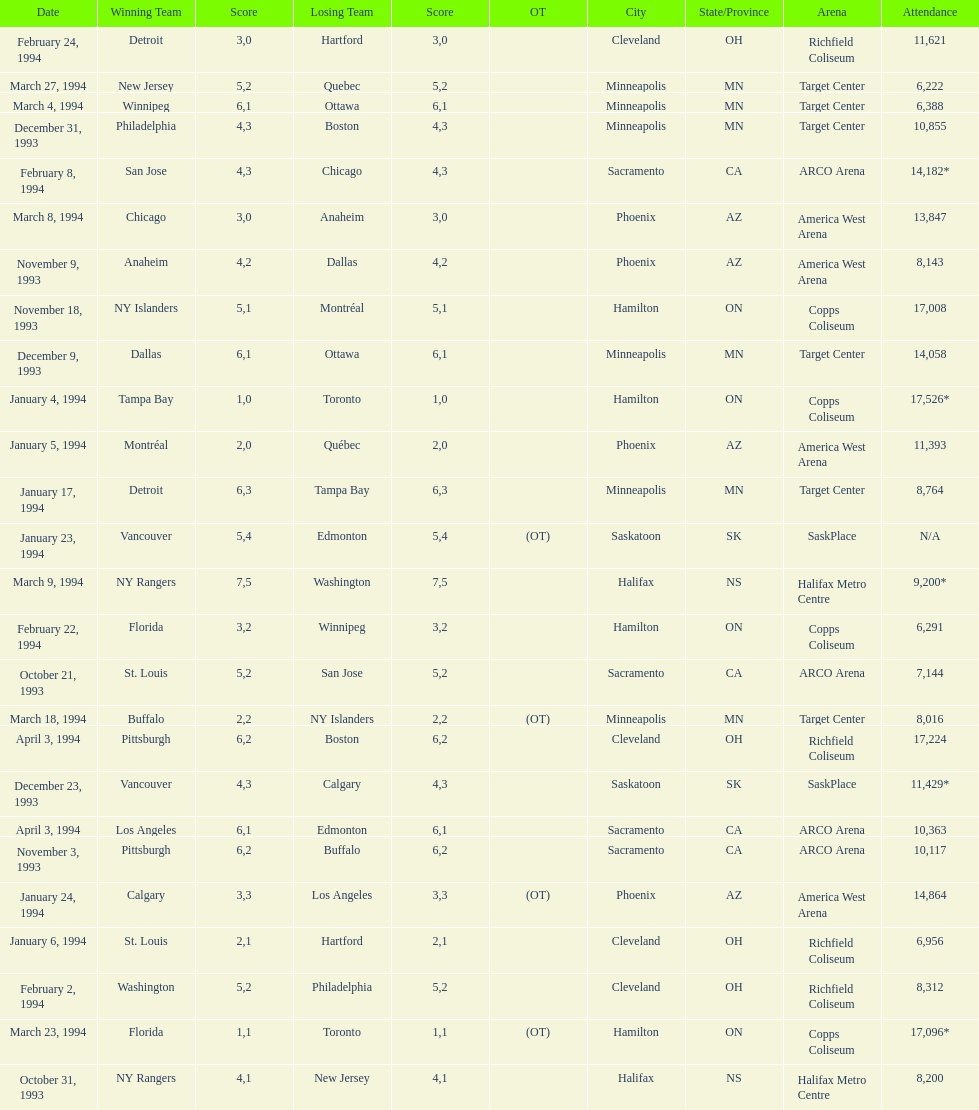Did dallas or ottawa win the december 9, 1993 game? Dallas. 